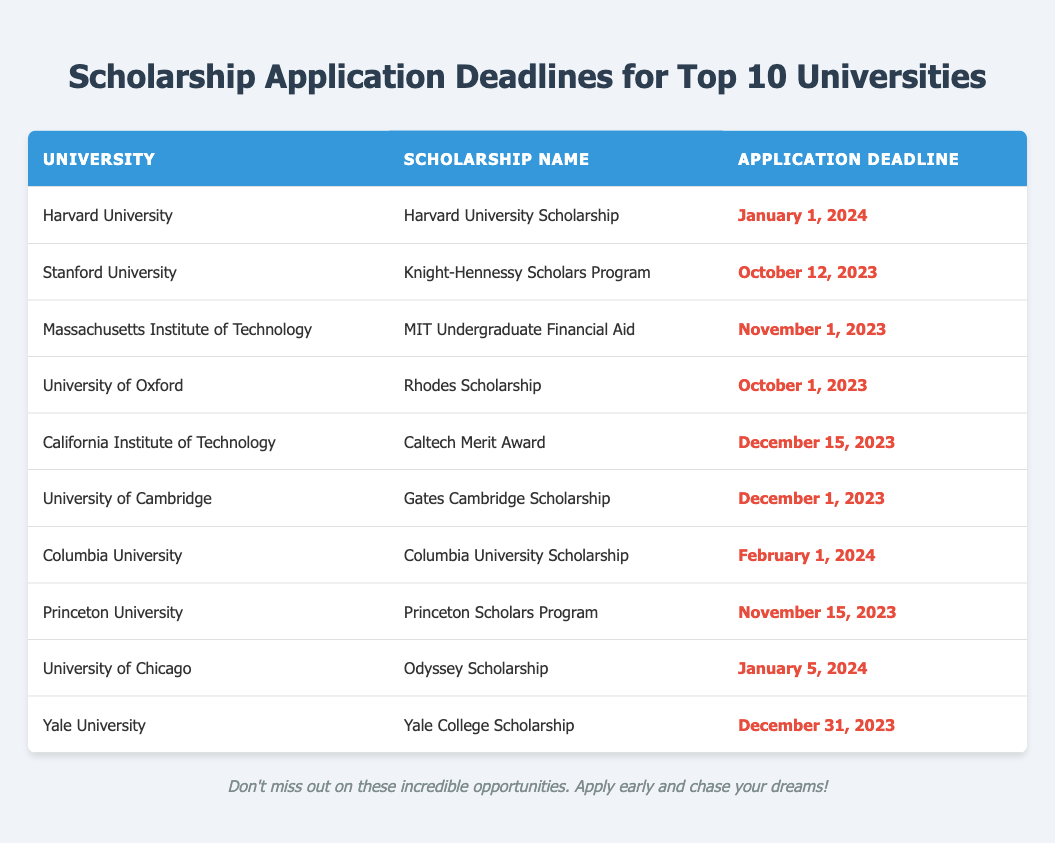What is the application deadline for the Rhodes Scholarship at the University of Oxford? The table indicates that the Rhodes Scholarship at the University of Oxford has an application deadline of October 1, 2023.
Answer: October 1, 2023 Which university has the latest scholarship application deadline in this table? To find this, we can look at the last application deadline date. The deadlines are January 1, 2024, for Harvard University, and February 1, 2024, for Columbia University. February 1, 2024, is the latest date. Therefore, Columbia University has the latest application deadline.
Answer: Columbia University Is the Caltech Merit Award application deadline before or after December 1, 2023? The Caltech Merit Award has an application deadline of December 15, 2023, which is after December 1, 2023.
Answer: After How many scholarships have deadlines in November 2023? We inspect the rows for the month of November and find two scholarships: MIT Undergraduate Financial Aid (November 1, 2023) and Princeton Scholars Program (November 15, 2023). Therefore, there are two scholarships with deadlines in November 2023.
Answer: 2 Which scholarship has an earlier deadline, MIT Undergraduate Financial Aid or Yale College Scholarship? The deadline for MIT Undergraduate Financial Aid is November 1, 2023, and for Yale College Scholarship, it is December 31, 2023. Since November 1 is earlier than December 31, the MIT scholarship has an earlier deadline.
Answer: MIT Undergraduate Financial Aid What percentage of the scholarships listed have deadlines in 2023? The table lists 10 scholarships, of which 7 have deadlines in 2023 (Stanford, MIT, Oxford, Caltech, Cambridge, Princeton, and Yale). To calculate the percentage, we use the formula (number of scholarships in 2023 / total scholarships) * 100 = (7/10) * 100 = 70%.
Answer: 70% Is it true that all scholarships listed have deadlines in the year 2024? Looking at the table, not all scholarships have deadlines in 2024; for instance, the Rhodes Scholarship and the Knight-Hennessy Scholars Program have deadlines in 2023. Therefore, the statement is false.
Answer: No What is the earliest application deadline among all the scholarships listed? To determine the earliest deadline, we compare all the dates. The earliest date is October 1, 2023, for the Rhodes Scholarship at the University of Oxford.
Answer: October 1, 2023 